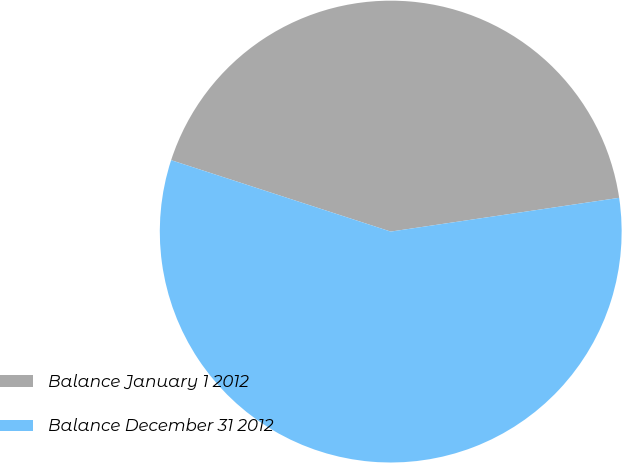Convert chart. <chart><loc_0><loc_0><loc_500><loc_500><pie_chart><fcel>Balance January 1 2012<fcel>Balance December 31 2012<nl><fcel>42.66%<fcel>57.34%<nl></chart> 